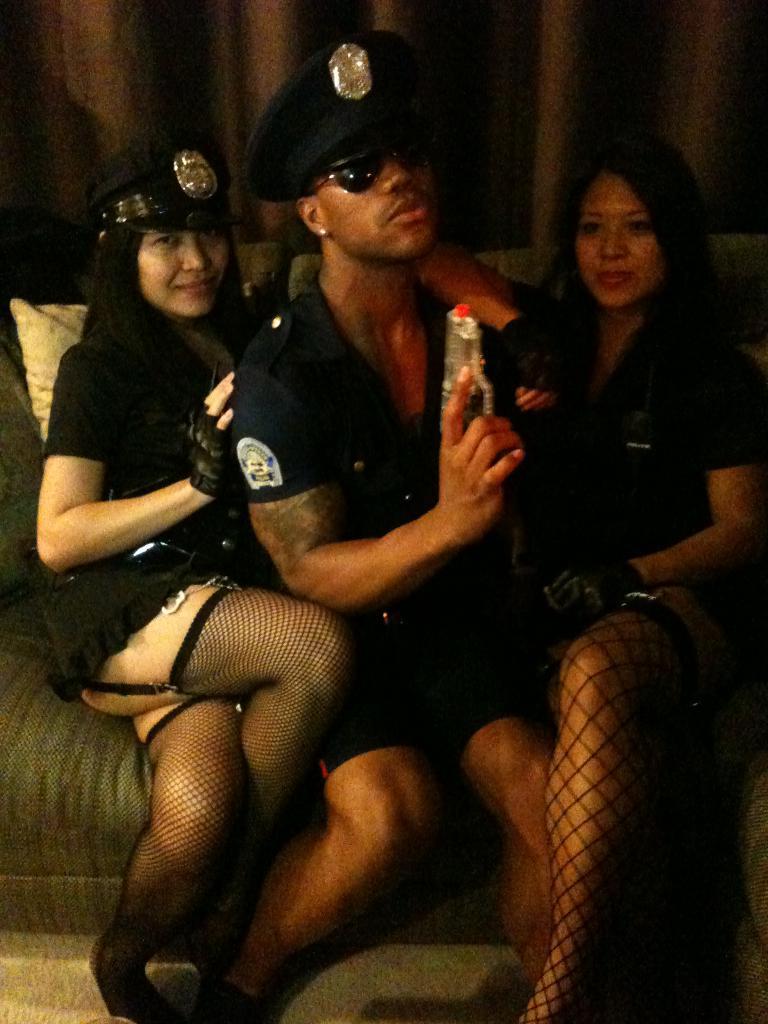Please provide a concise description of this image. In this image, I can see the man and two women sitting on the couch. In the background, these look like the curtains hanging. 